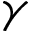Convert formula to latex. <formula><loc_0><loc_0><loc_500><loc_500>\gamma</formula> 